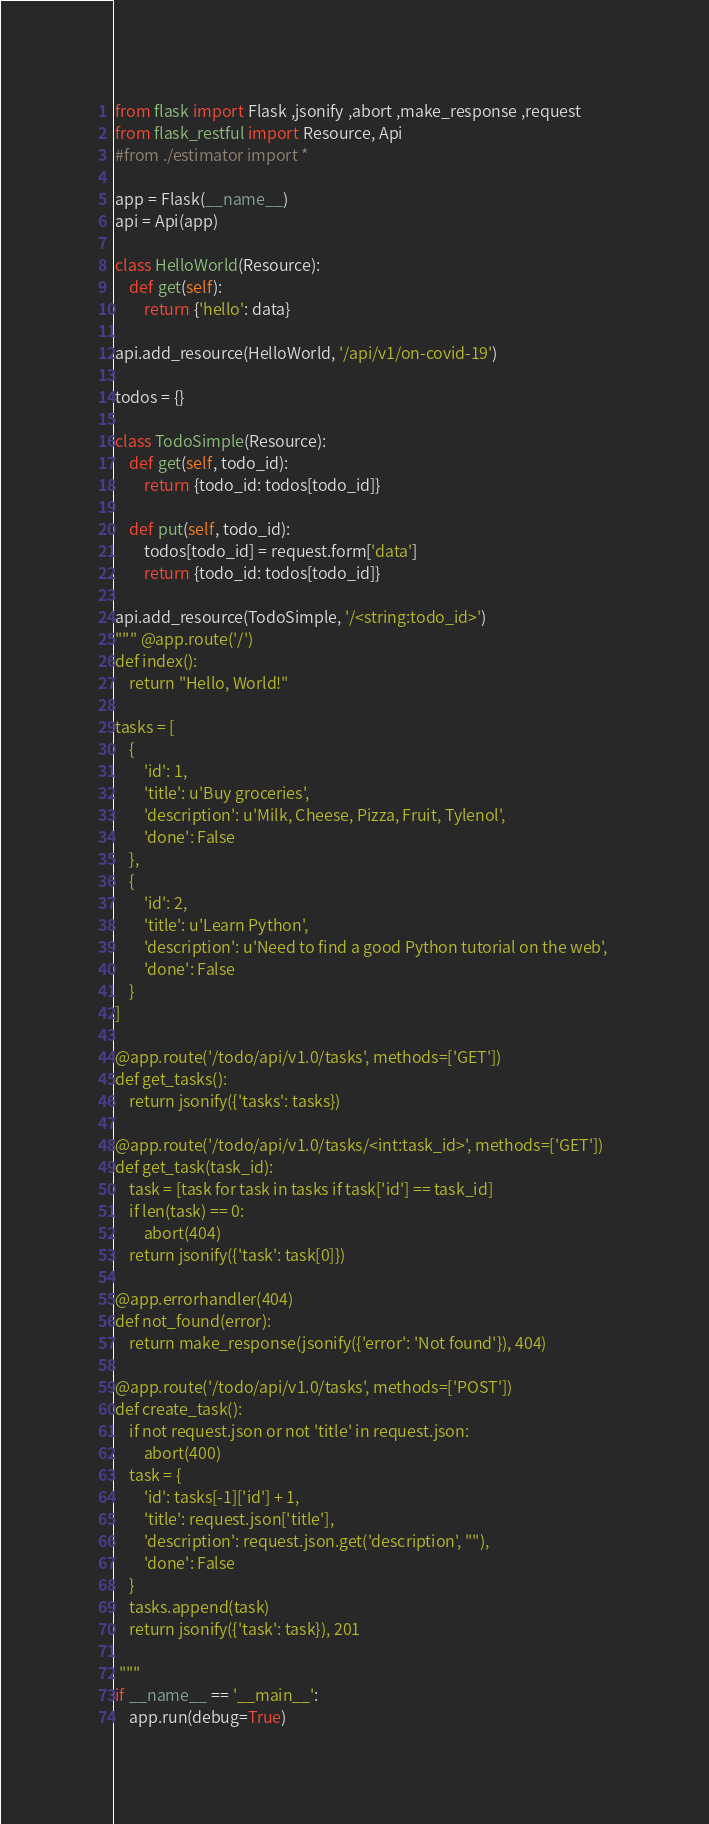<code> <loc_0><loc_0><loc_500><loc_500><_Python_>from flask import Flask ,jsonify ,abort ,make_response ,request
from flask_restful import Resource, Api
#from ./estimator import *

app = Flask(__name__)
api = Api(app)

class HelloWorld(Resource):
    def get(self):
        return {'hello': data}

api.add_resource(HelloWorld, '/api/v1/on-covid-19')

todos = {}

class TodoSimple(Resource):
    def get(self, todo_id):
        return {todo_id: todos[todo_id]}

    def put(self, todo_id):
        todos[todo_id] = request.form['data']
        return {todo_id: todos[todo_id]}

api.add_resource(TodoSimple, '/<string:todo_id>')
""" @app.route('/')
def index():
    return "Hello, World!"

tasks = [
    {
        'id': 1,
        'title': u'Buy groceries',
        'description': u'Milk, Cheese, Pizza, Fruit, Tylenol', 
        'done': False
    },
    {
        'id': 2,
        'title': u'Learn Python',
        'description': u'Need to find a good Python tutorial on the web', 
        'done': False
    }
]

@app.route('/todo/api/v1.0/tasks', methods=['GET'])
def get_tasks():
    return jsonify({'tasks': tasks})

@app.route('/todo/api/v1.0/tasks/<int:task_id>', methods=['GET'])
def get_task(task_id):
    task = [task for task in tasks if task['id'] == task_id]
    if len(task) == 0:
        abort(404)
    return jsonify({'task': task[0]})

@app.errorhandler(404)
def not_found(error):
    return make_response(jsonify({'error': 'Not found'}), 404)

@app.route('/todo/api/v1.0/tasks', methods=['POST'])
def create_task():
    if not request.json or not 'title' in request.json:
        abort(400)
    task = {
        'id': tasks[-1]['id'] + 1,
        'title': request.json['title'],
        'description': request.json.get('description', ""),
        'done': False
    }
    tasks.append(task)
    return jsonify({'task': task}), 201

 """
if __name__ == '__main__':
    app.run(debug=True)</code> 